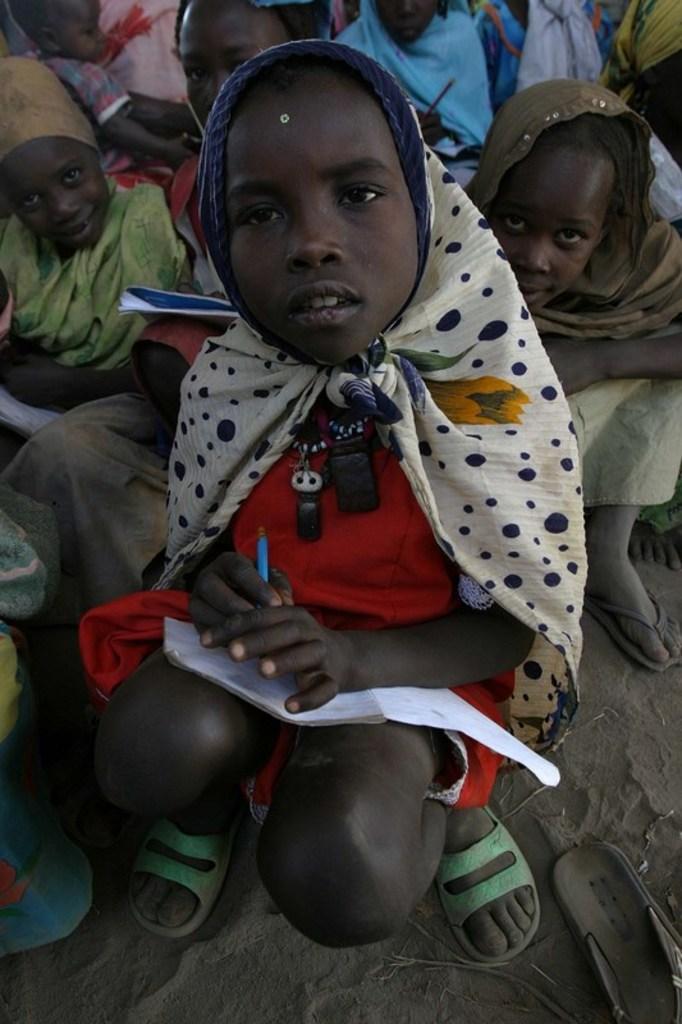Describe this image in one or two sentences. This image consists of many children. In the front, we can see a child wearing a scarf and holding a book. At the bottom, there is sand. 